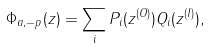<formula> <loc_0><loc_0><loc_500><loc_500>\Phi _ { a , - p } ( z ) = \sum _ { i } P _ { i } ( z ^ { ( O ) } ) Q _ { i } ( z ^ { ( I ) } ) ,</formula> 